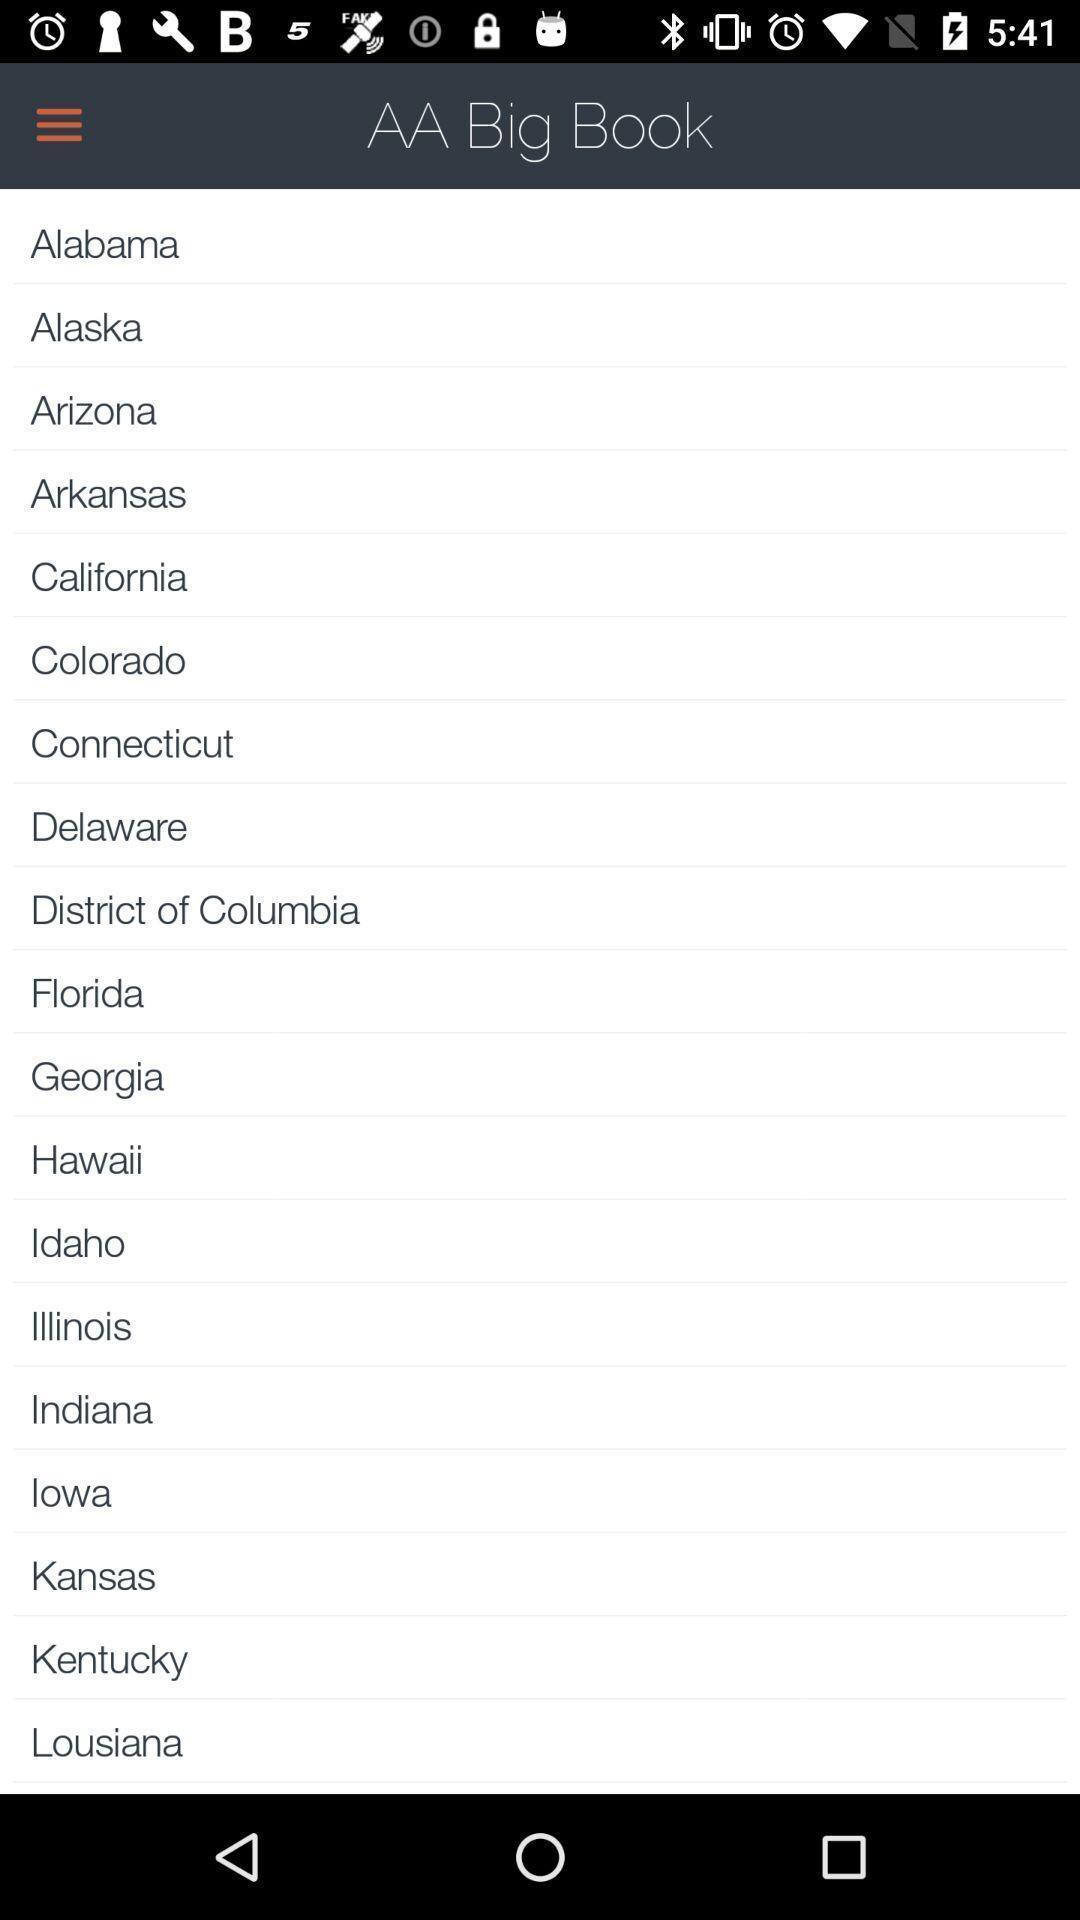Provide a description of this screenshot. Page showing features in an ebook. 